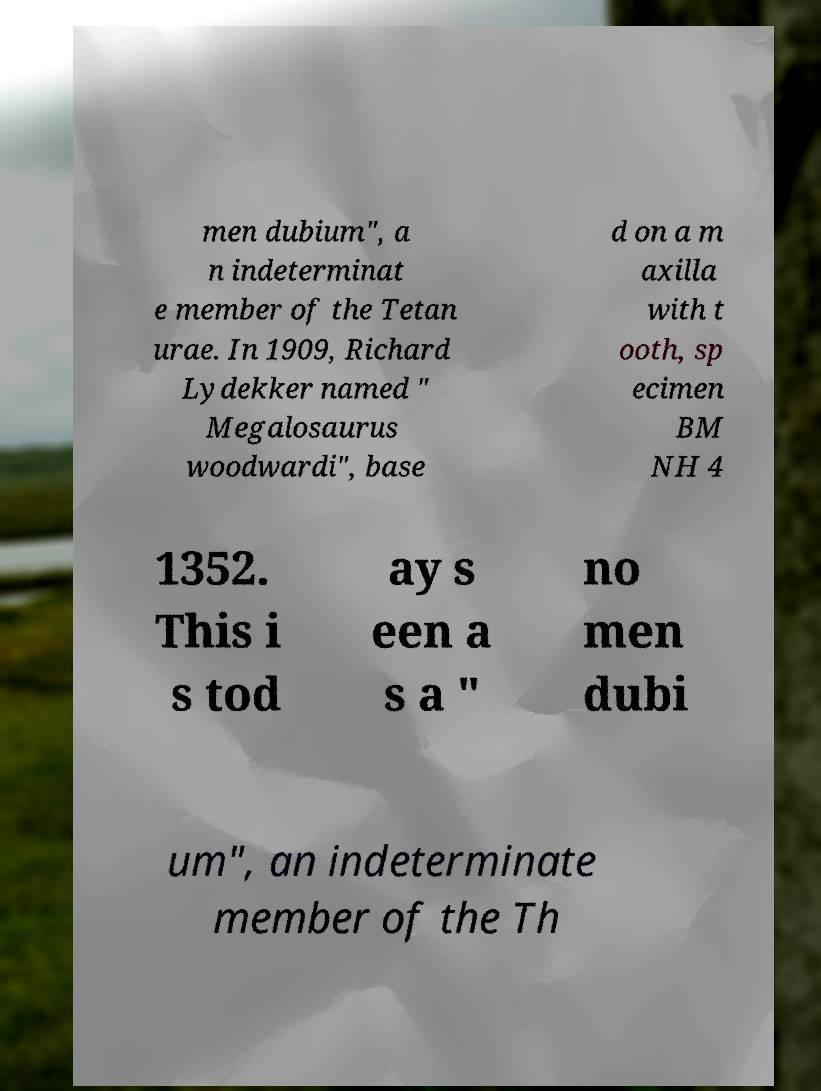Can you accurately transcribe the text from the provided image for me? men dubium", a n indeterminat e member of the Tetan urae. In 1909, Richard Lydekker named " Megalosaurus woodwardi", base d on a m axilla with t ooth, sp ecimen BM NH 4 1352. This i s tod ay s een a s a " no men dubi um", an indeterminate member of the Th 